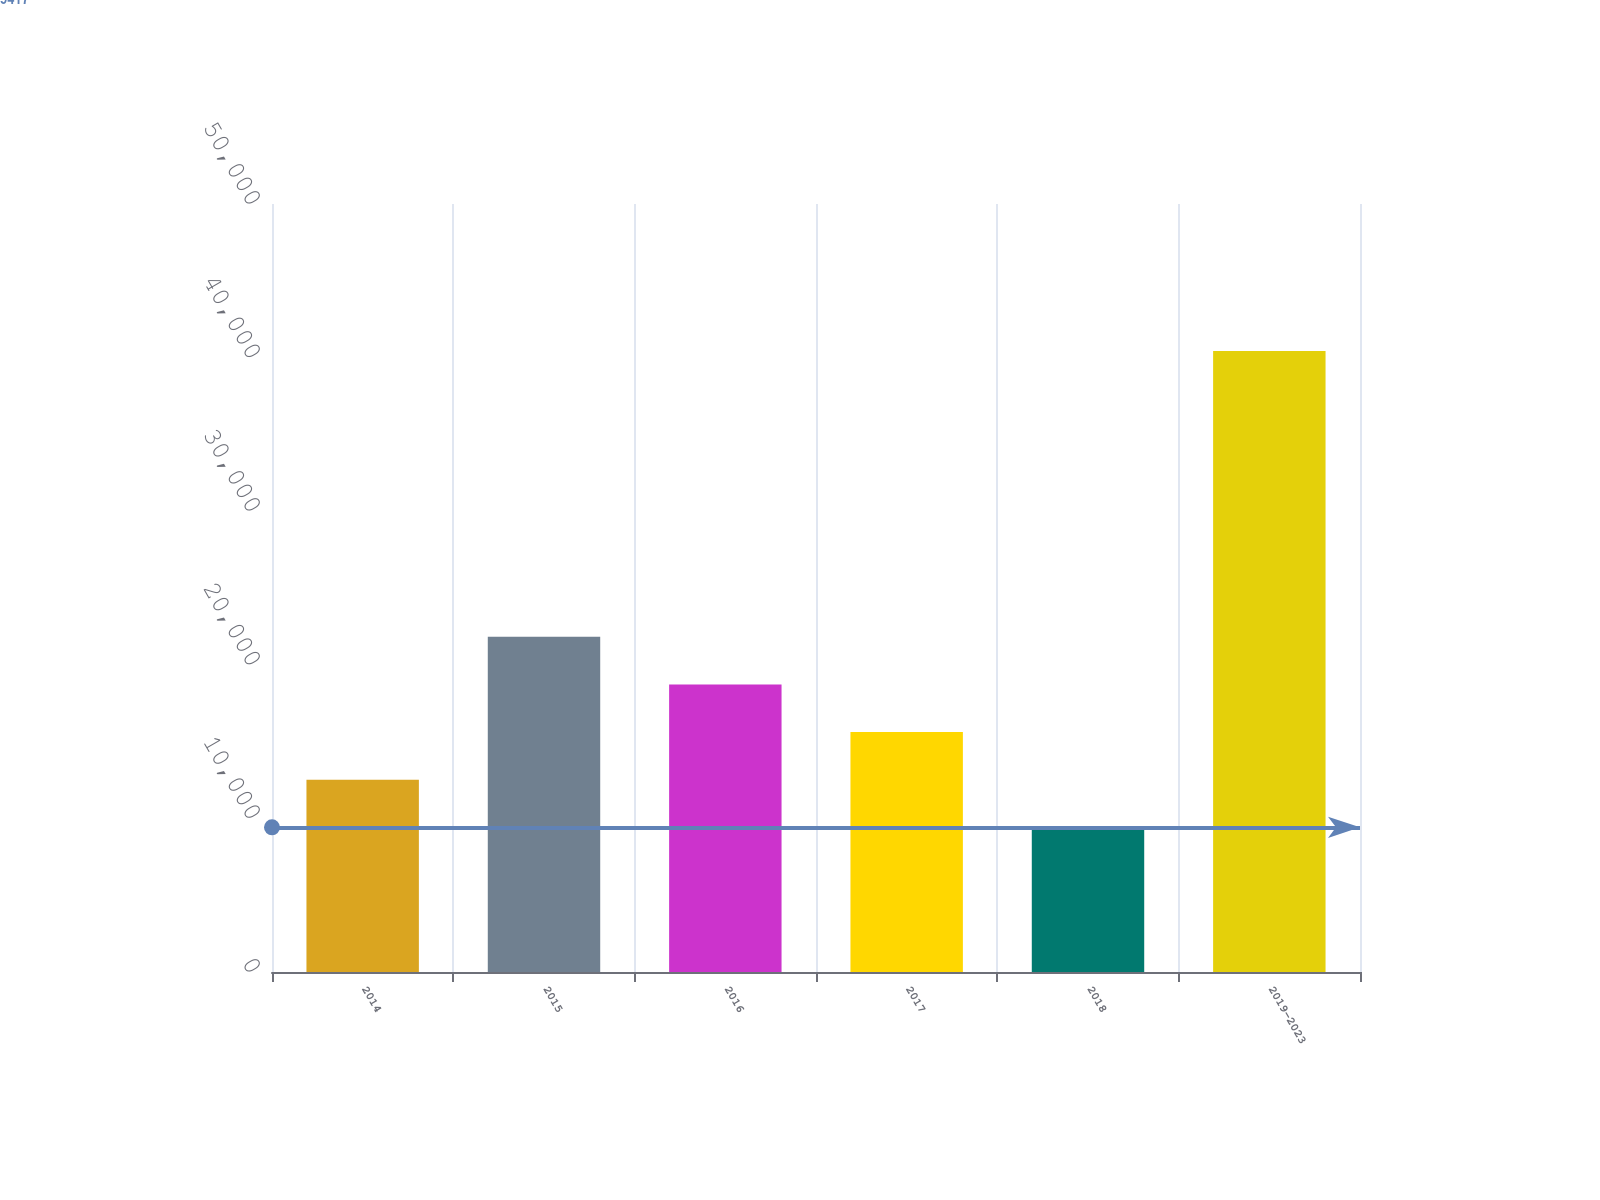Convert chart to OTSL. <chart><loc_0><loc_0><loc_500><loc_500><bar_chart><fcel>2014<fcel>2015<fcel>2016<fcel>2017<fcel>2018<fcel>2019-2023<nl><fcel>12518.2<fcel>21821.8<fcel>18720.6<fcel>15619.4<fcel>9417<fcel>40429<nl></chart> 